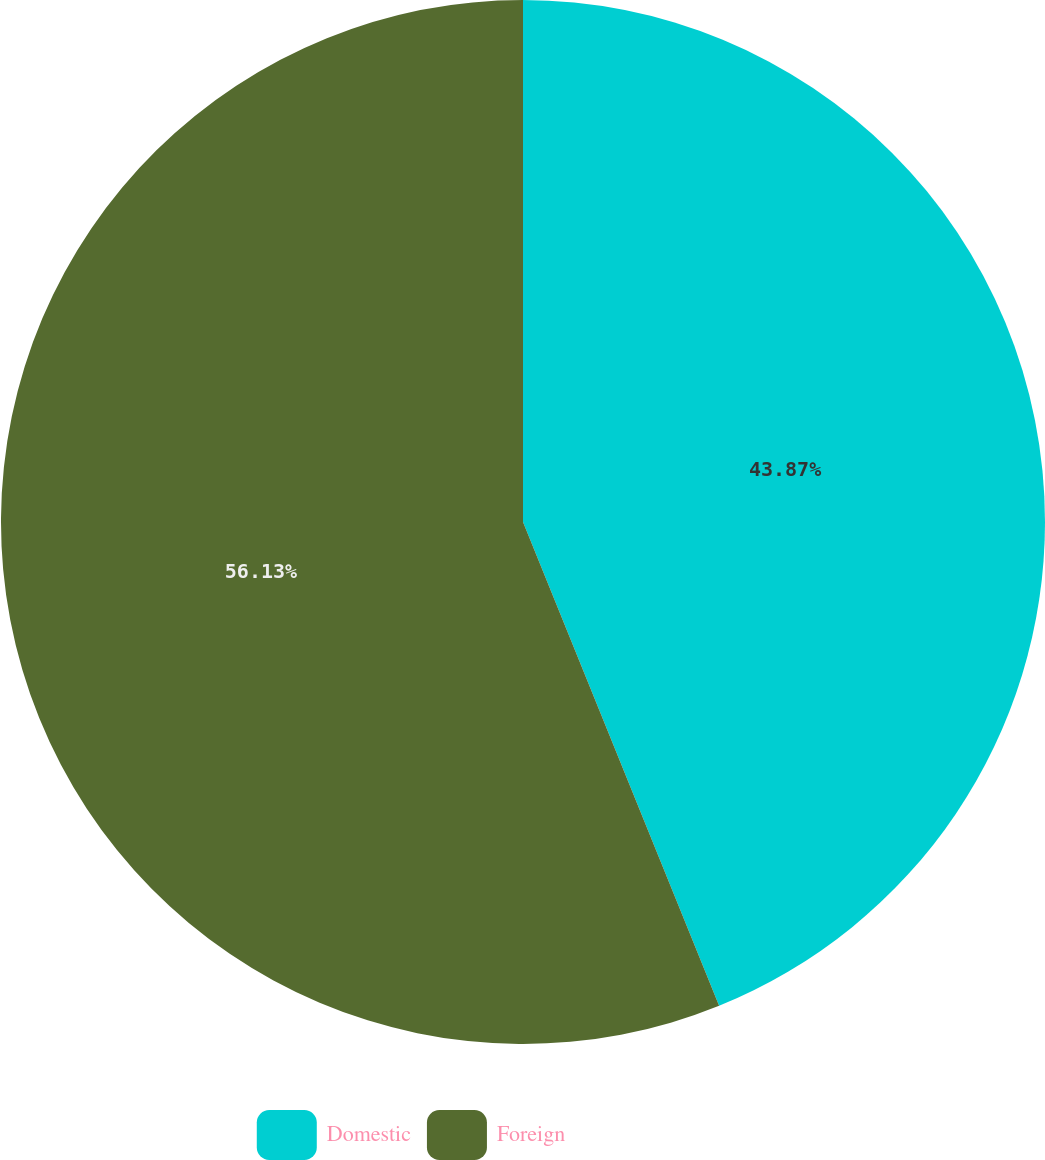<chart> <loc_0><loc_0><loc_500><loc_500><pie_chart><fcel>Domestic<fcel>Foreign<nl><fcel>43.87%<fcel>56.13%<nl></chart> 